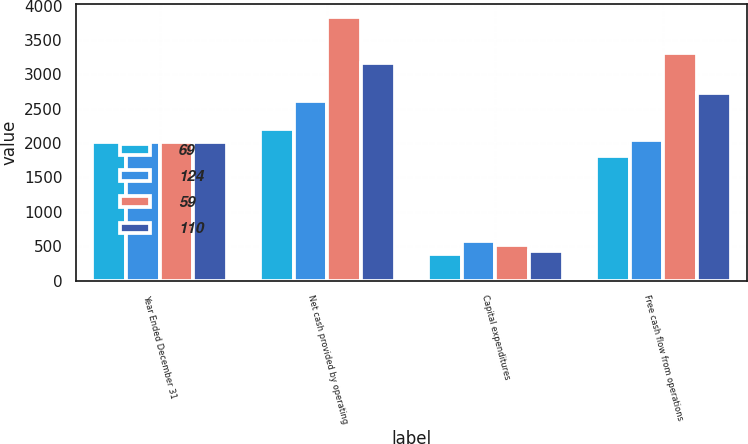<chart> <loc_0><loc_0><loc_500><loc_500><stacked_bar_chart><ecel><fcel>Year Ended December 31<fcel>Net cash provided by operating<fcel>Capital expenditures<fcel>Free cash flow from operations<nl><fcel>69<fcel>2016<fcel>2198<fcel>392<fcel>1806<nl><fcel>124<fcel>2015<fcel>2607<fcel>569<fcel>2038<nl><fcel>59<fcel>2014<fcel>3828<fcel>521<fcel>3307<nl><fcel>110<fcel>2013<fcel>3159<fcel>436<fcel>2723<nl></chart> 